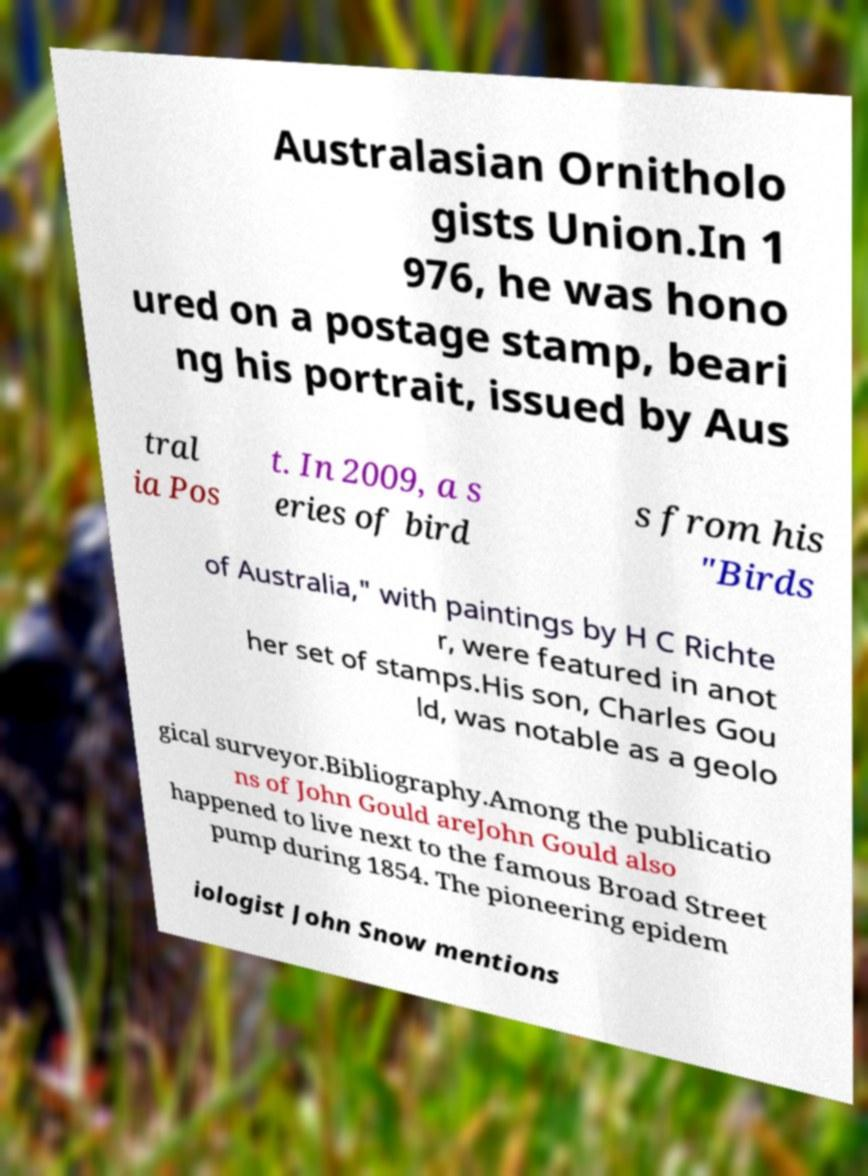Can you accurately transcribe the text from the provided image for me? Australasian Ornitholo gists Union.In 1 976, he was hono ured on a postage stamp, beari ng his portrait, issued by Aus tral ia Pos t. In 2009, a s eries of bird s from his "Birds of Australia," with paintings by H C Richte r, were featured in anot her set of stamps.His son, Charles Gou ld, was notable as a geolo gical surveyor.Bibliography.Among the publicatio ns of John Gould areJohn Gould also happened to live next to the famous Broad Street pump during 1854. The pioneering epidem iologist John Snow mentions 